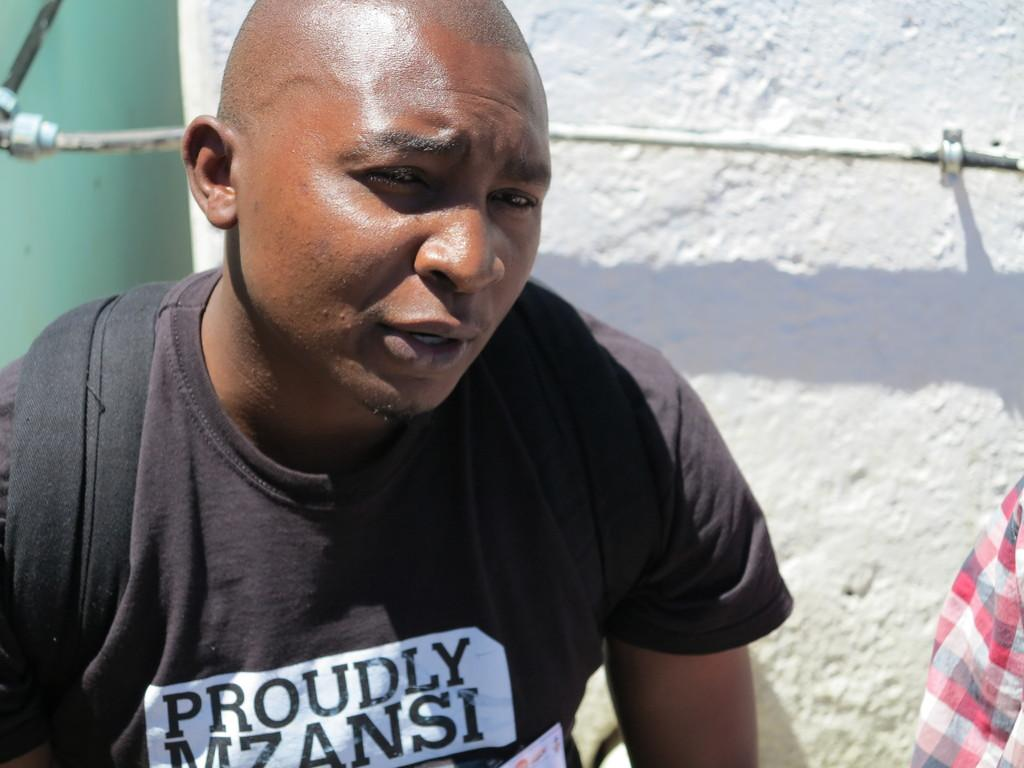How many people are in the image? There are two persons in the image. Can you describe one of the persons? One of the persons is a man. What is the man wearing in the image? The man is wearing a black T-shirt. What can be seen in the background of the image? There is a wall in the background of the image. What type of tank can be seen in the image? There is no tank present in the image. What is the man using to stir the flesh in the image? There is no flesh or stirring utensil present in the image. 